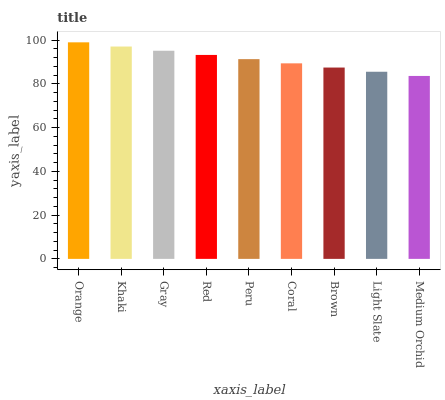Is Khaki the minimum?
Answer yes or no. No. Is Khaki the maximum?
Answer yes or no. No. Is Orange greater than Khaki?
Answer yes or no. Yes. Is Khaki less than Orange?
Answer yes or no. Yes. Is Khaki greater than Orange?
Answer yes or no. No. Is Orange less than Khaki?
Answer yes or no. No. Is Peru the high median?
Answer yes or no. Yes. Is Peru the low median?
Answer yes or no. Yes. Is Brown the high median?
Answer yes or no. No. Is Gray the low median?
Answer yes or no. No. 